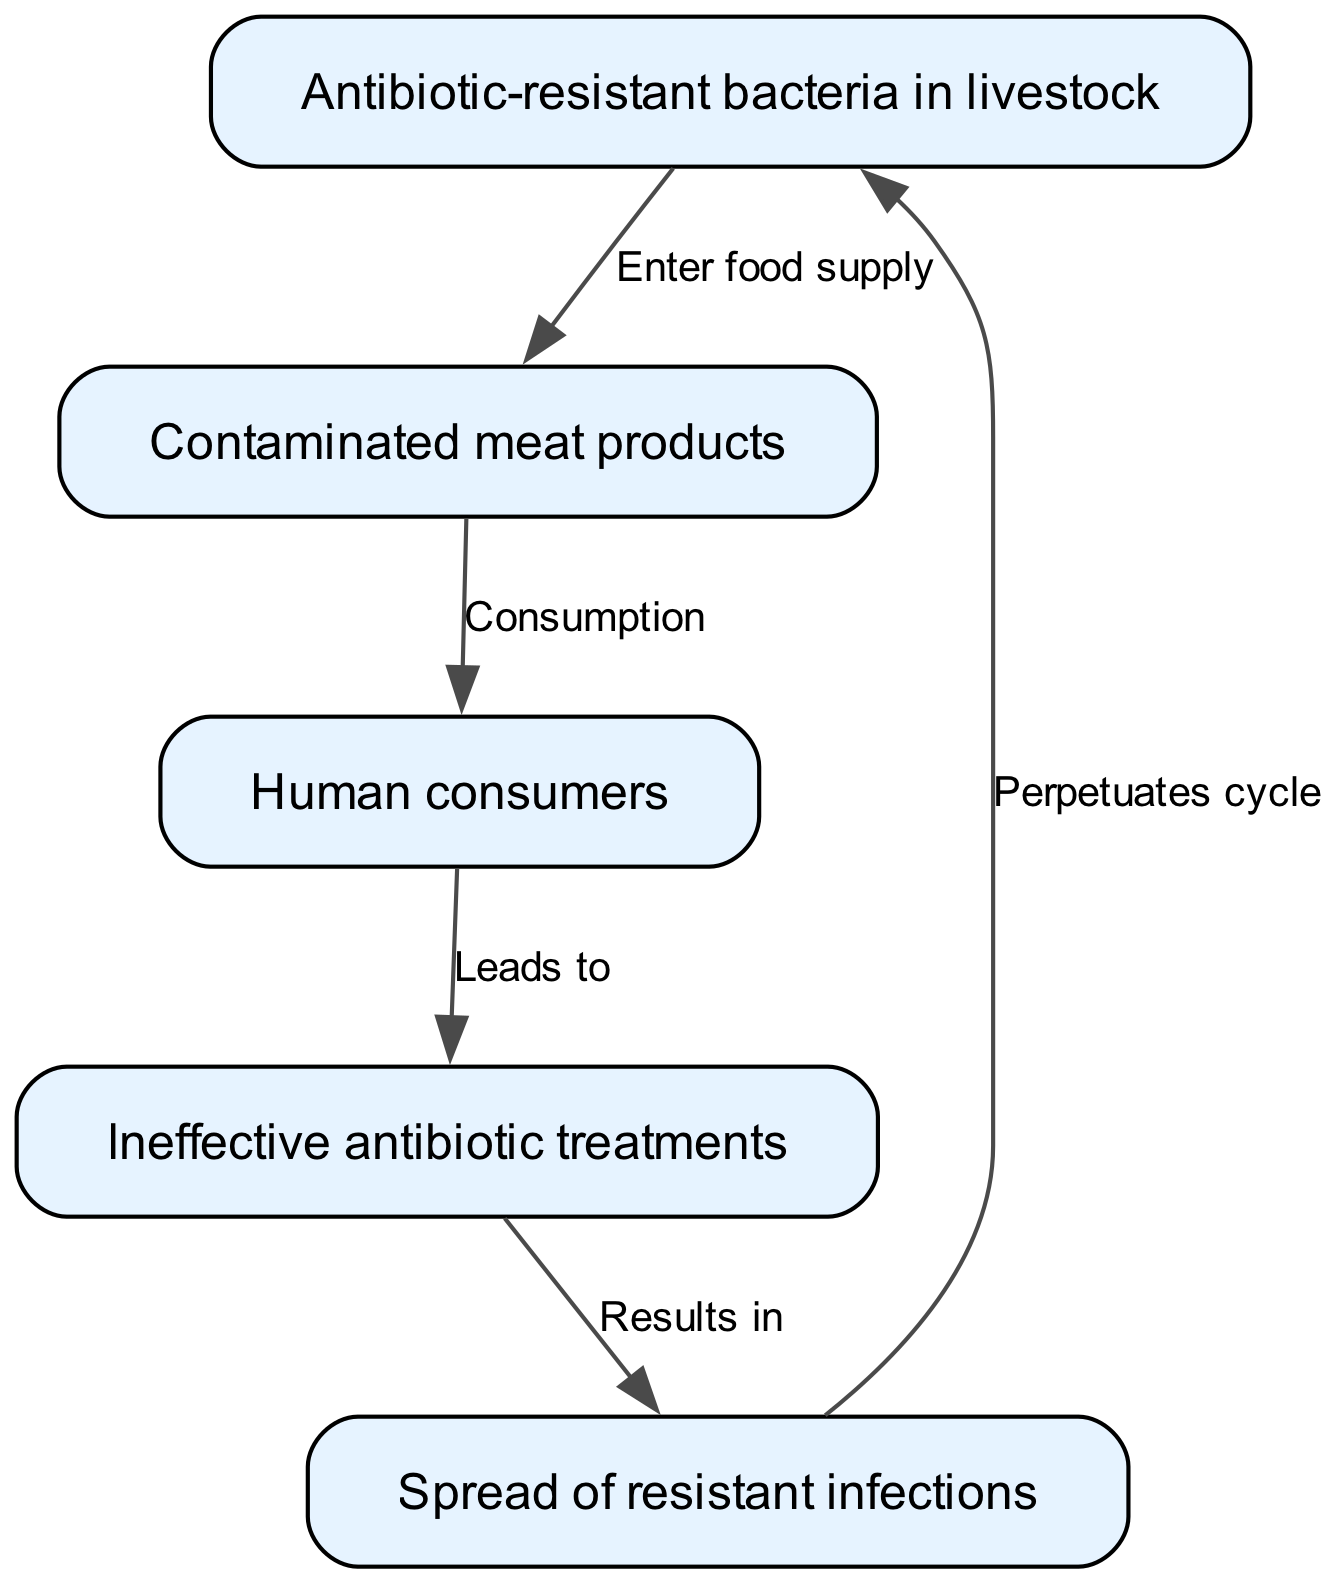What is the first node in the food chain? The first node in the food chain is labeled "Antibiotic-resistant bacteria in livestock". This can be identified as the initial point of the flow diagram.
Answer: Antibiotic-resistant bacteria in livestock How many nodes are present in the diagram? The diagram includes five nodes: "Antibiotic-resistant bacteria in livestock", "Contaminated meat products", "Human consumers", "Ineffective antibiotic treatments", and "Spread of resistant infections". Counting these gives a total of five.
Answer: 5 What leads to ineffective antibiotic treatments in humans? The process that leads to ineffective antibiotic treatments is represented as "Consumption", specifically highlighting the link from "Human consumers" to "Ineffective antibiotic treatments" which indicates that by consuming contaminated meat products, humans may face this issue.
Answer: Consumption Which node results from the spread of resistant infections? The node that results from the spread of resistant infections is "Antibiotic-resistant bacteria in livestock". This reflects how the cycle perpetuates, showing that resistant infections contribute back to the source of the problem.
Answer: Antibiotic-resistant bacteria in livestock What is the relationship between "Contaminated meat products" and "Human consumers"? The relationship between "Contaminated meat products" and "Human consumers" is a direct action labeled "Consumption", indicating that humans consume these products directly.
Answer: Consumption How do ineffective antibiotic treatments affect the food chain? Ineffective antibiotic treatments lead to "Spread of resistant infections", which disrupts the overall health chain by increasing the prevalence of resistant bacteria affecting humans and livestock alike, thereby perpetuating the cycle.
Answer: Spread of resistant infections What kind of cycle is perpetuated in the food chain? The cycle that is perpetuated in the food chain is a cycle of antibiotic resistance, illustrating how the initial problem (antibiotic-resistant bacteria in livestock) continues to propagate through various nodes and interactions.
Answer: Antibiotic resistance cycle What does the arrow from "Human consumers" to "Ineffective antibiotic treatments" indicate? The arrow represents a causal relationship where the consumption of contaminated meat products by humans directly impacts the effectiveness of antibiotic treatments, emphasizing how dietary choices can have significant health implications.
Answer: Leads to How does the "Spread of resistant infections" relate back to the first node? The "Spread of resistant infections" is shown to lead back to "Antibiotic-resistant bacteria in livestock", indicating that the infections affect livestock populations, thus perpetuating the cycle of resistance back to its source.
Answer: Perpetuates cycle 